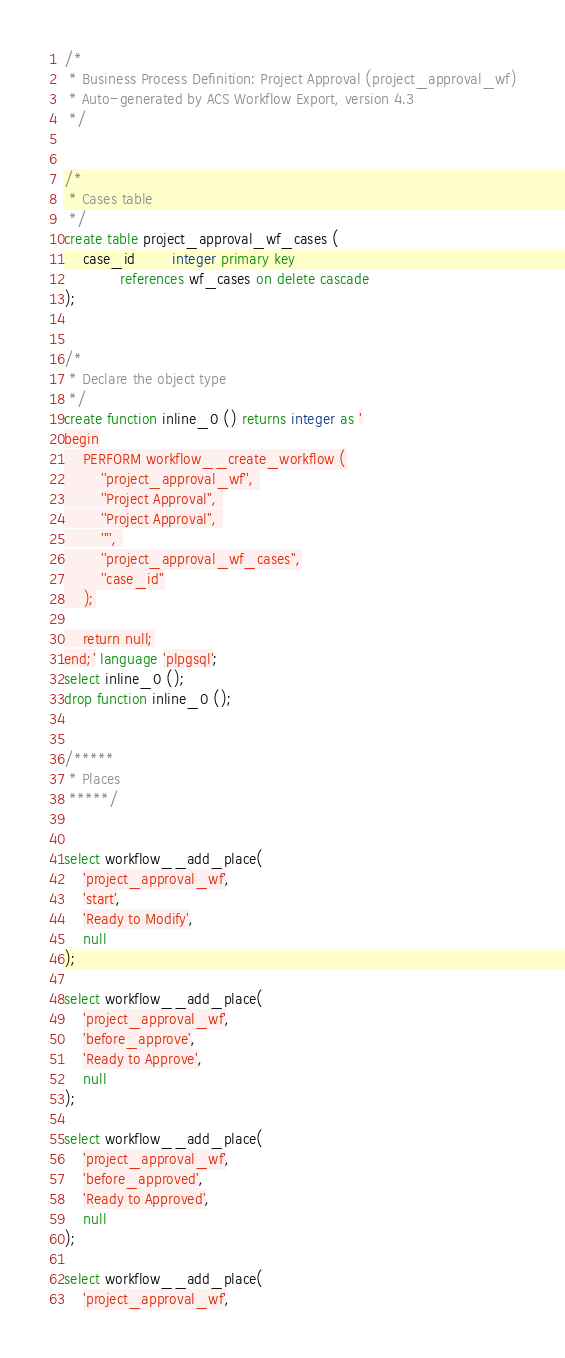Convert code to text. <code><loc_0><loc_0><loc_500><loc_500><_SQL_>/*
 * Business Process Definition: Project Approval (project_approval_wf)
 * Auto-generated by ACS Workflow Export, version 4.3
 */


/*
 * Cases table
 */
create table project_approval_wf_cases (
	case_id		integer primary key
			references wf_cases on delete cascade
);


/* 
 * Declare the object type
 */
create function inline_0 () returns integer as '
begin
	PERFORM workflow__create_workflow (
		''project_approval_wf'', 
		''Project Approval'', 
		''Project Approval'', 
		'''', 
		''project_approval_wf_cases'',
		''case_id''
	);

	return null;
end;' language 'plpgsql';
select inline_0 ();
drop function inline_0 ();

	
/*****
 * Places
 *****/


select workflow__add_place(
	'project_approval_wf',
	'start', 
	'Ready to Modify', 
	null
);

select workflow__add_place(
	'project_approval_wf',
	'before_approve', 
	'Ready to Approve', 
	null
);

select workflow__add_place(
	'project_approval_wf',
	'before_approved', 
	'Ready to Approved', 
	null
);

select workflow__add_place(
	'project_approval_wf',</code> 